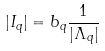<formula> <loc_0><loc_0><loc_500><loc_500>| I _ { q } | = b _ { q } \frac { 1 } { | \Lambda _ { q } | }</formula> 